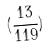Convert formula to latex. <formula><loc_0><loc_0><loc_500><loc_500>( \frac { 1 3 } { 1 1 9 } )</formula> 